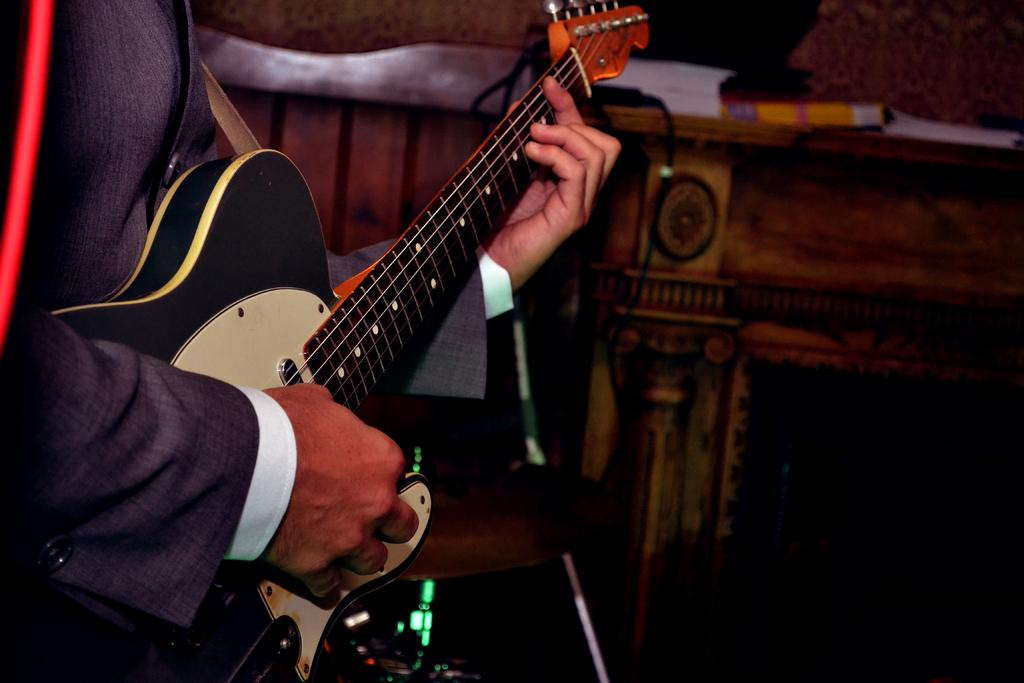What is the main subject of the image? The main subject of the image is a partial part of a human. What activity is the human engaged in? The human is playing a guitar. What type of board is visible in the image? There is no board present in the image. How many legs can be seen in the image? The image only shows a partial part of a human, so it is not possible to determine the number of legs. 